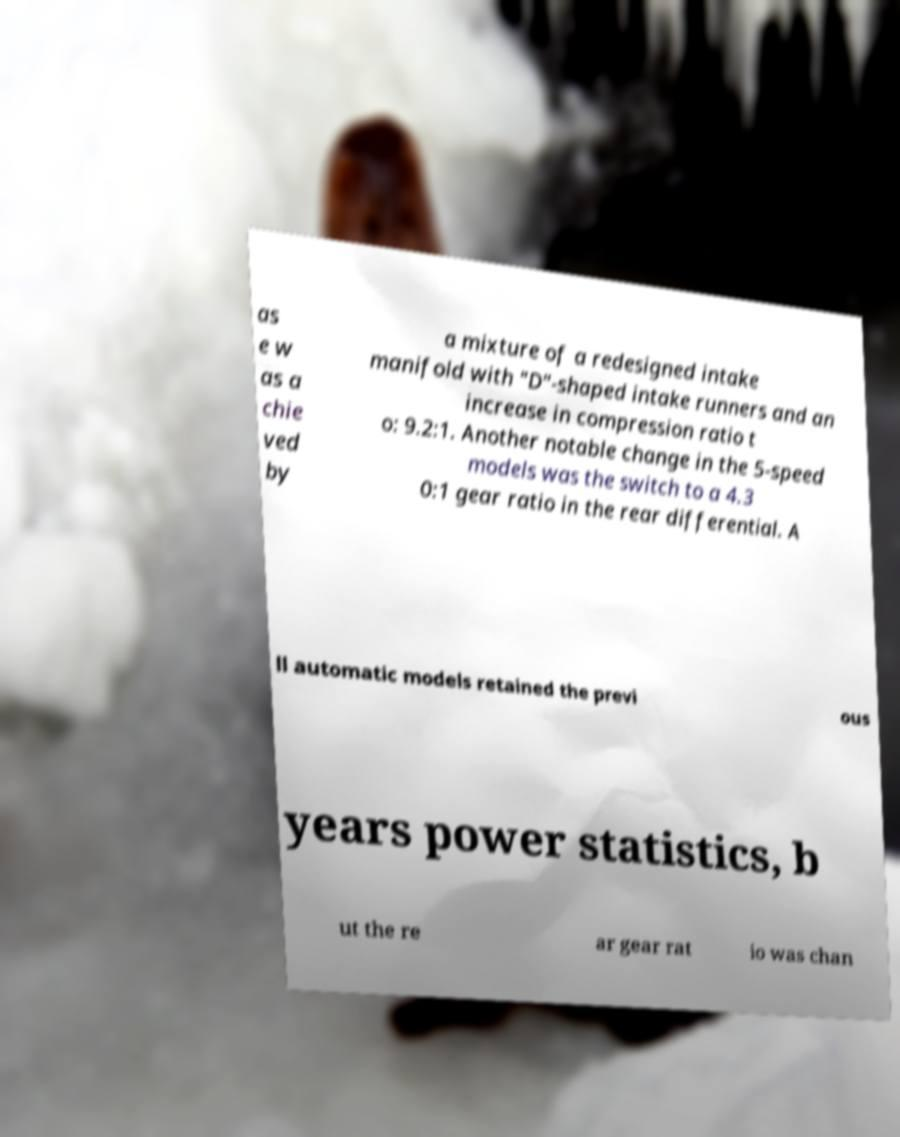Please identify and transcribe the text found in this image. as e w as a chie ved by a mixture of a redesigned intake manifold with "D"-shaped intake runners and an increase in compression ratio t o: 9.2:1. Another notable change in the 5-speed models was the switch to a 4.3 0:1 gear ratio in the rear differential. A ll automatic models retained the previ ous years power statistics, b ut the re ar gear rat io was chan 